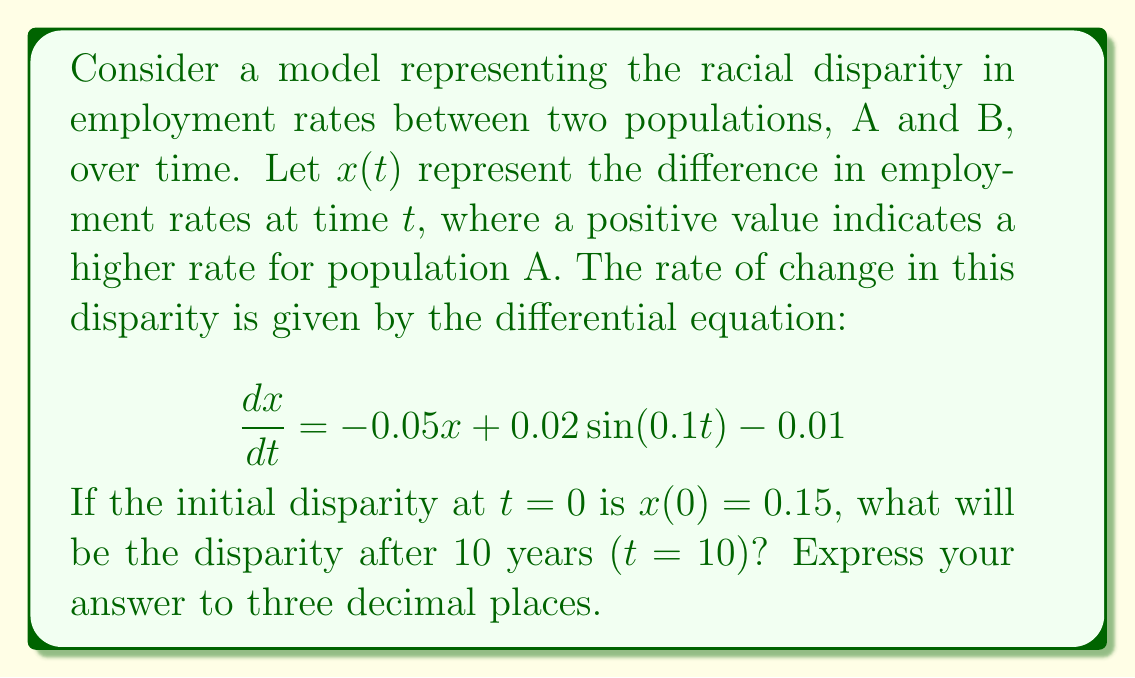Help me with this question. To solve this problem, we need to use the general solution for a first-order linear differential equation with a non-homogeneous term. The steps are as follows:

1) The general form of the equation is:
   $$\frac{dx}{dt} + 0.05x = 0.02\sin(0.1t) - 0.01$$

2) The integrating factor is $e^{\int 0.05 dt} = e^{0.05t}$

3) Multiplying both sides by the integrating factor:
   $$e^{0.05t}\frac{dx}{dt} + 0.05xe^{0.05t} = (0.02\sin(0.1t) - 0.01)e^{0.05t}$$

4) The left side is now the derivative of $xe^{0.05t}$:
   $$\frac{d}{dt}(xe^{0.05t}) = (0.02\sin(0.1t) - 0.01)e^{0.05t}$$

5) Integrating both sides:
   $$xe^{0.05t} = \int (0.02\sin(0.1t) - 0.01)e^{0.05t} dt + C$$

6) Solving the integral:
   $$xe^{0.05t} = 0.02e^{0.05t}(\frac{0.05\sin(0.1t) - 0.1\cos(0.1t)}{0.0125}) - 0.2e^{0.05t} + C$$

7) Simplifying:
   $$x = 0.02(\frac{0.05\sin(0.1t) - 0.1\cos(0.1t)}{0.0125}) - 0.2 + Ce^{-0.05t}$$

8) Using the initial condition $x(0) = 0.15$ to find $C$:
   $$0.15 = 0.02(\frac{-0.1}{0.0125}) - 0.2 + C$$
   $$C = 0.15 + 0.2 + 0.16 = 0.51$$

9) The complete solution is:
   $$x(t) = 0.02(\frac{0.05\sin(0.1t) - 0.1\cos(0.1t)}{0.0125}) - 0.2 + 0.51e^{-0.05t}$$

10) Evaluating at $t=10$:
    $$x(10) = 0.02(\frac{0.05\sin(1) - 0.1\cos(1)}{0.0125}) - 0.2 + 0.51e^{-0.5}$$

11) Calculating the final value:
    $$x(10) \approx 0.080 - 0.2 + 0.309 = 0.189$$
Answer: 0.189 